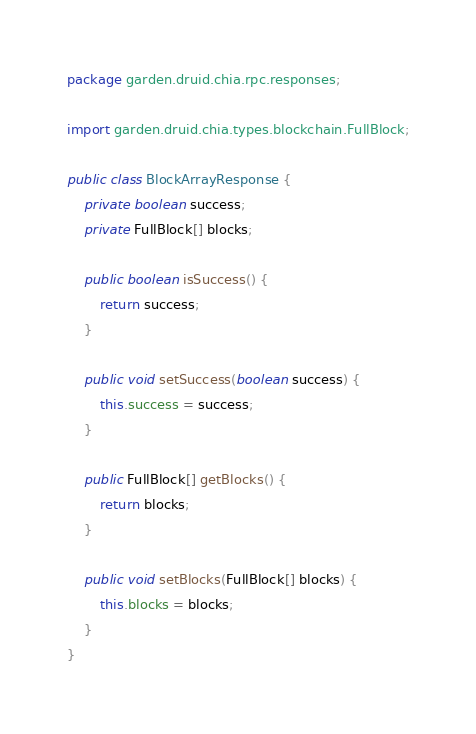<code> <loc_0><loc_0><loc_500><loc_500><_Java_>package garden.druid.chia.rpc.responses;

import garden.druid.chia.types.blockchain.FullBlock;

public class BlockArrayResponse {
	private boolean success;
	private FullBlock[] blocks;

	public boolean isSuccess() {
		return success;
	}

	public void setSuccess(boolean success) {
		this.success = success;
	}

	public FullBlock[] getBlocks() {
		return blocks;
	}

	public void setBlocks(FullBlock[] blocks) {
		this.blocks = blocks;
	}
}
</code> 